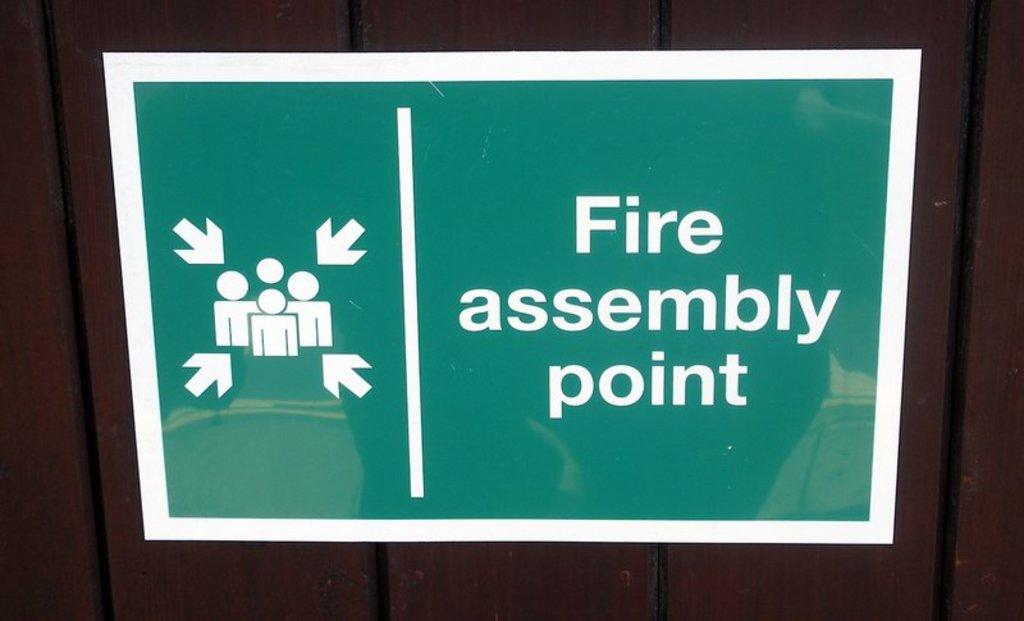<image>
Create a compact narrative representing the image presented. A sign that says fire assembly point is being shown. 